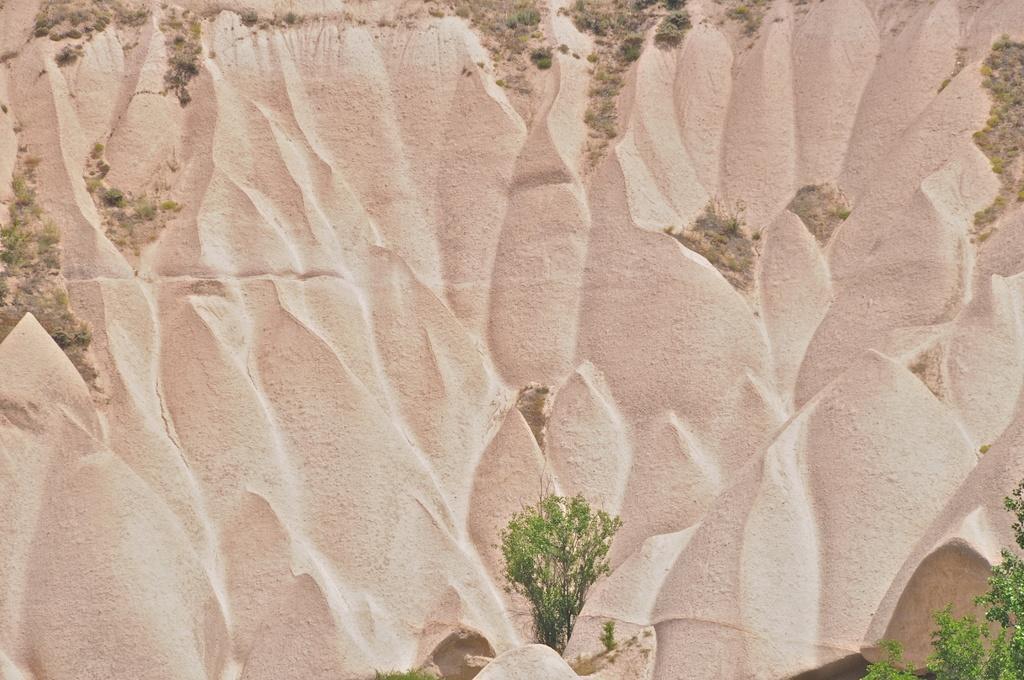In one or two sentences, can you explain what this image depicts? In this picture we can see the plants and carving on the wall. 